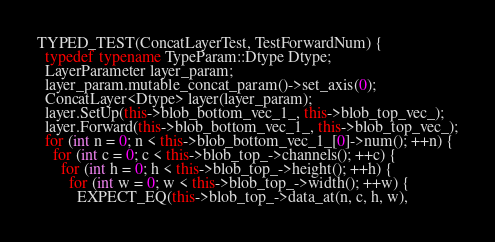<code> <loc_0><loc_0><loc_500><loc_500><_C++_>TYPED_TEST(ConcatLayerTest, TestForwardNum) {
  typedef typename TypeParam::Dtype Dtype;
  LayerParameter layer_param;
  layer_param.mutable_concat_param()->set_axis(0);
  ConcatLayer<Dtype> layer(layer_param);
  layer.SetUp(this->blob_bottom_vec_1_, this->blob_top_vec_);
  layer.Forward(this->blob_bottom_vec_1_, this->blob_top_vec_);
  for (int n = 0; n < this->blob_bottom_vec_1_[0]->num(); ++n) {
    for (int c = 0; c < this->blob_top_->channels(); ++c) {
      for (int h = 0; h < this->blob_top_->height(); ++h) {
        for (int w = 0; w < this->blob_top_->width(); ++w) {
          EXPECT_EQ(this->blob_top_->data_at(n, c, h, w),</code> 